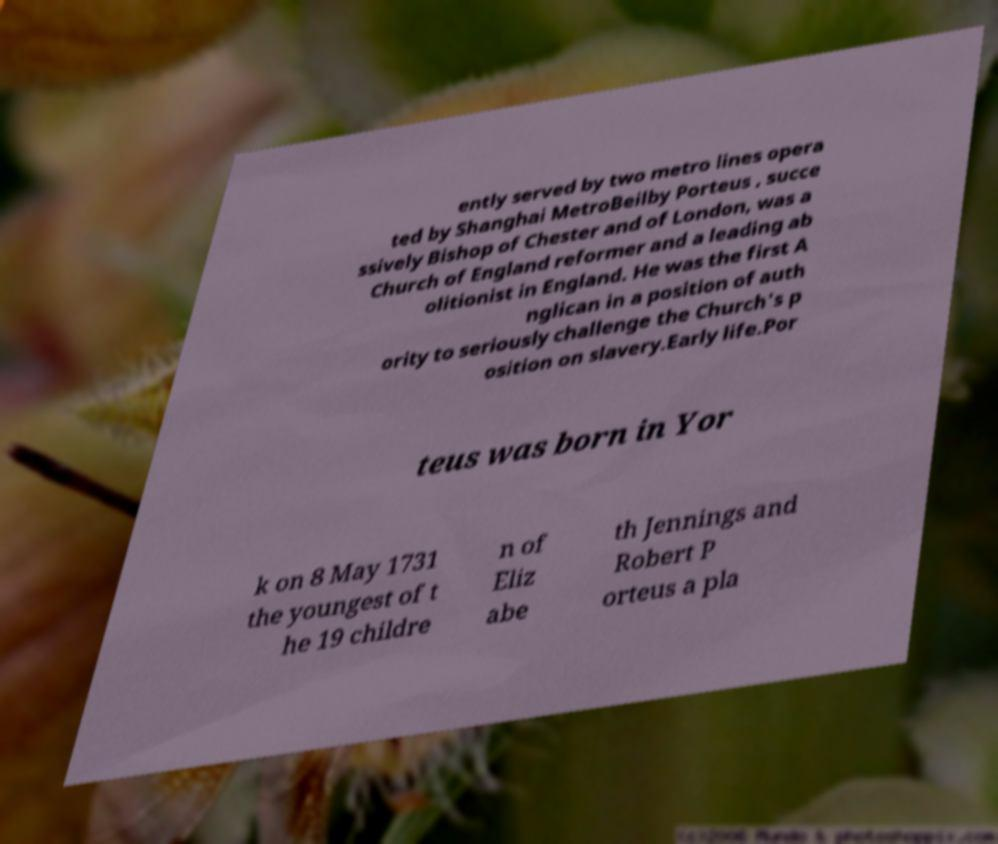Please identify and transcribe the text found in this image. ently served by two metro lines opera ted by Shanghai MetroBeilby Porteus , succe ssively Bishop of Chester and of London, was a Church of England reformer and a leading ab olitionist in England. He was the first A nglican in a position of auth ority to seriously challenge the Church's p osition on slavery.Early life.Por teus was born in Yor k on 8 May 1731 the youngest of t he 19 childre n of Eliz abe th Jennings and Robert P orteus a pla 